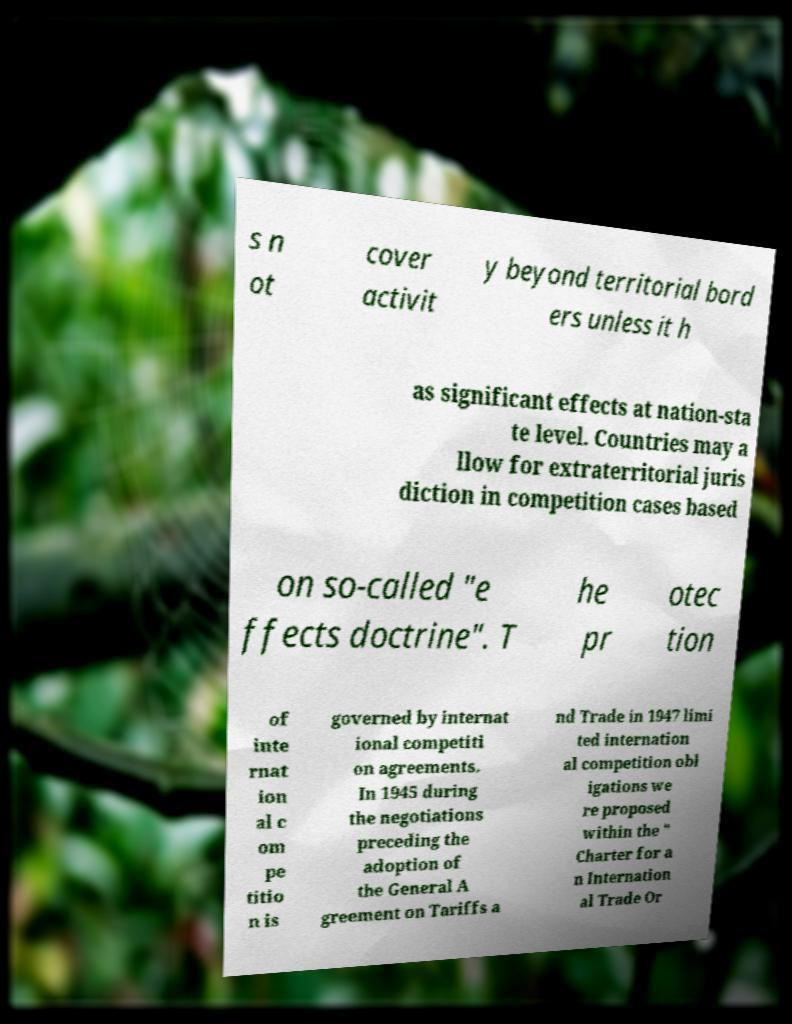Please read and relay the text visible in this image. What does it say? s n ot cover activit y beyond territorial bord ers unless it h as significant effects at nation-sta te level. Countries may a llow for extraterritorial juris diction in competition cases based on so-called "e ffects doctrine". T he pr otec tion of inte rnat ion al c om pe titio n is governed by internat ional competiti on agreements. In 1945 during the negotiations preceding the adoption of the General A greement on Tariffs a nd Trade in 1947 limi ted internation al competition obl igations we re proposed within the " Charter for a n Internation al Trade Or 